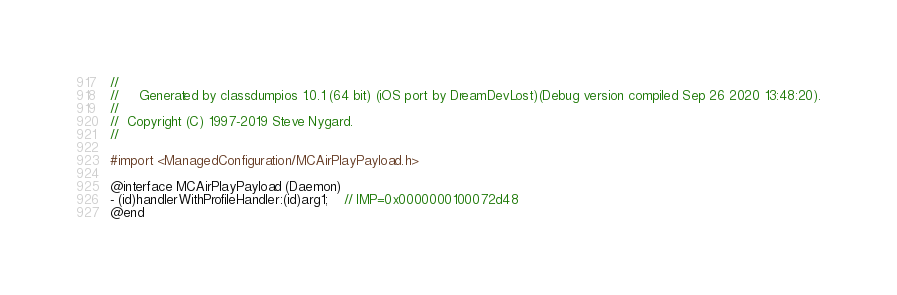Convert code to text. <code><loc_0><loc_0><loc_500><loc_500><_C_>//
//     Generated by classdumpios 1.0.1 (64 bit) (iOS port by DreamDevLost)(Debug version compiled Sep 26 2020 13:48:20).
//
//  Copyright (C) 1997-2019 Steve Nygard.
//

#import <ManagedConfiguration/MCAirPlayPayload.h>

@interface MCAirPlayPayload (Daemon)
- (id)handlerWithProfileHandler:(id)arg1;	// IMP=0x0000000100072d48
@end

</code> 